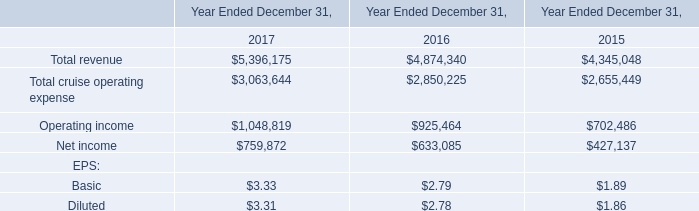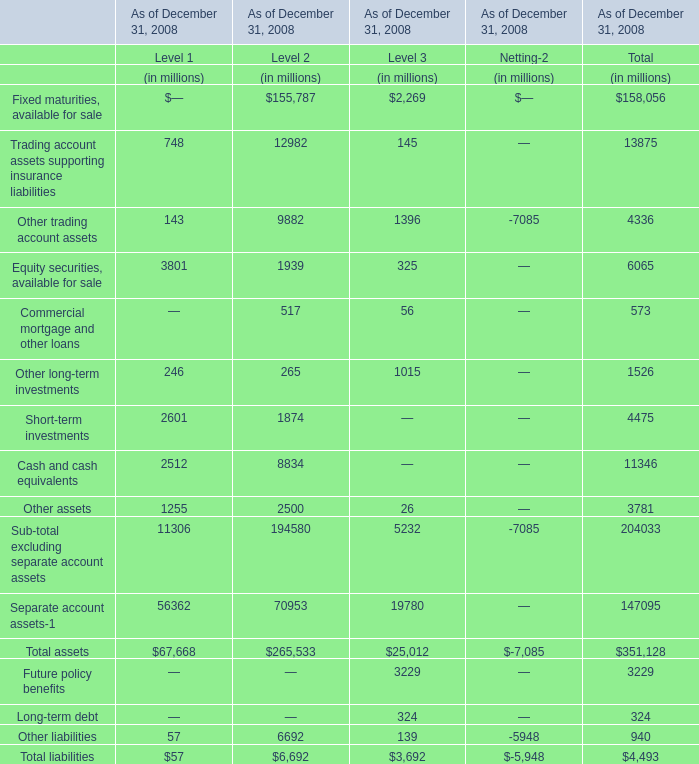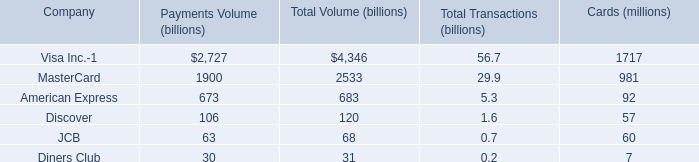Between Level 2 and Level 3,which Level is Total assets as of December 31, 2008 greater than 100000 million? 
Answer: 2. 